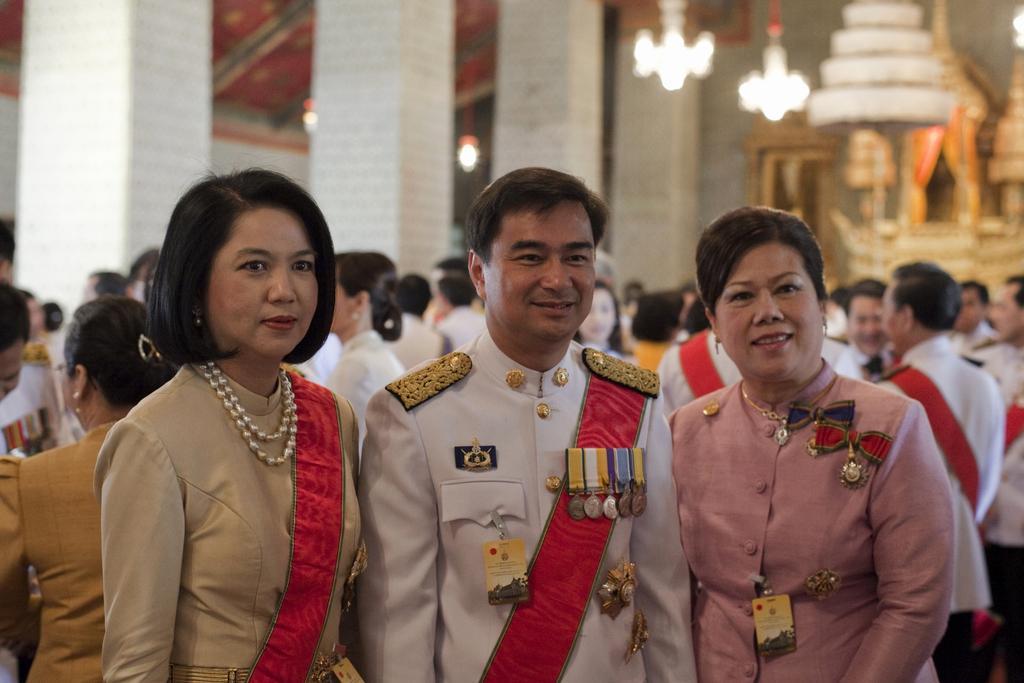Could you give a brief overview of what you see in this image? In this image I can see a man wearing cream and red colored dress is standing and two women standing besides him. In the background I can see number of persons standing, few white colored pillars, few lights and few other blurry objects. 